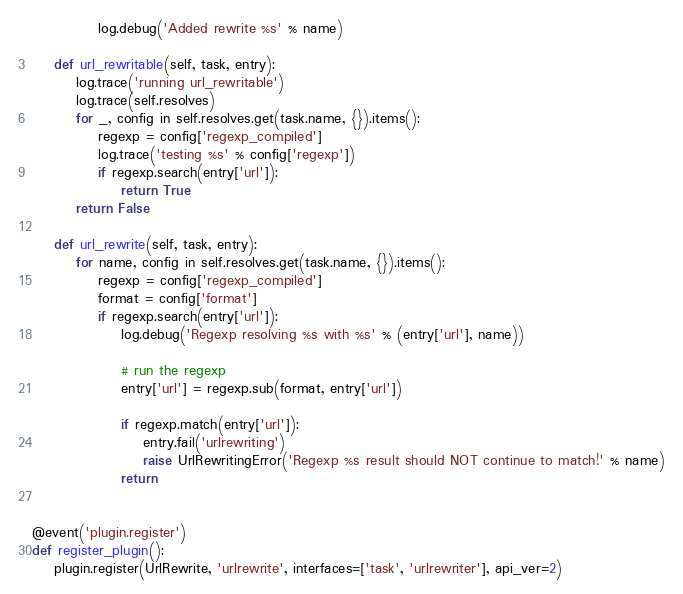<code> <loc_0><loc_0><loc_500><loc_500><_Python_>            log.debug('Added rewrite %s' % name)

    def url_rewritable(self, task, entry):
        log.trace('running url_rewritable')
        log.trace(self.resolves)
        for _, config in self.resolves.get(task.name, {}).items():
            regexp = config['regexp_compiled']
            log.trace('testing %s' % config['regexp'])
            if regexp.search(entry['url']):
                return True
        return False

    def url_rewrite(self, task, entry):
        for name, config in self.resolves.get(task.name, {}).items():
            regexp = config['regexp_compiled']
            format = config['format']
            if regexp.search(entry['url']):
                log.debug('Regexp resolving %s with %s' % (entry['url'], name))

                # run the regexp
                entry['url'] = regexp.sub(format, entry['url'])

                if regexp.match(entry['url']):
                    entry.fail('urlrewriting')
                    raise UrlRewritingError('Regexp %s result should NOT continue to match!' % name)
                return


@event('plugin.register')
def register_plugin():
    plugin.register(UrlRewrite, 'urlrewrite', interfaces=['task', 'urlrewriter'], api_ver=2)
</code> 